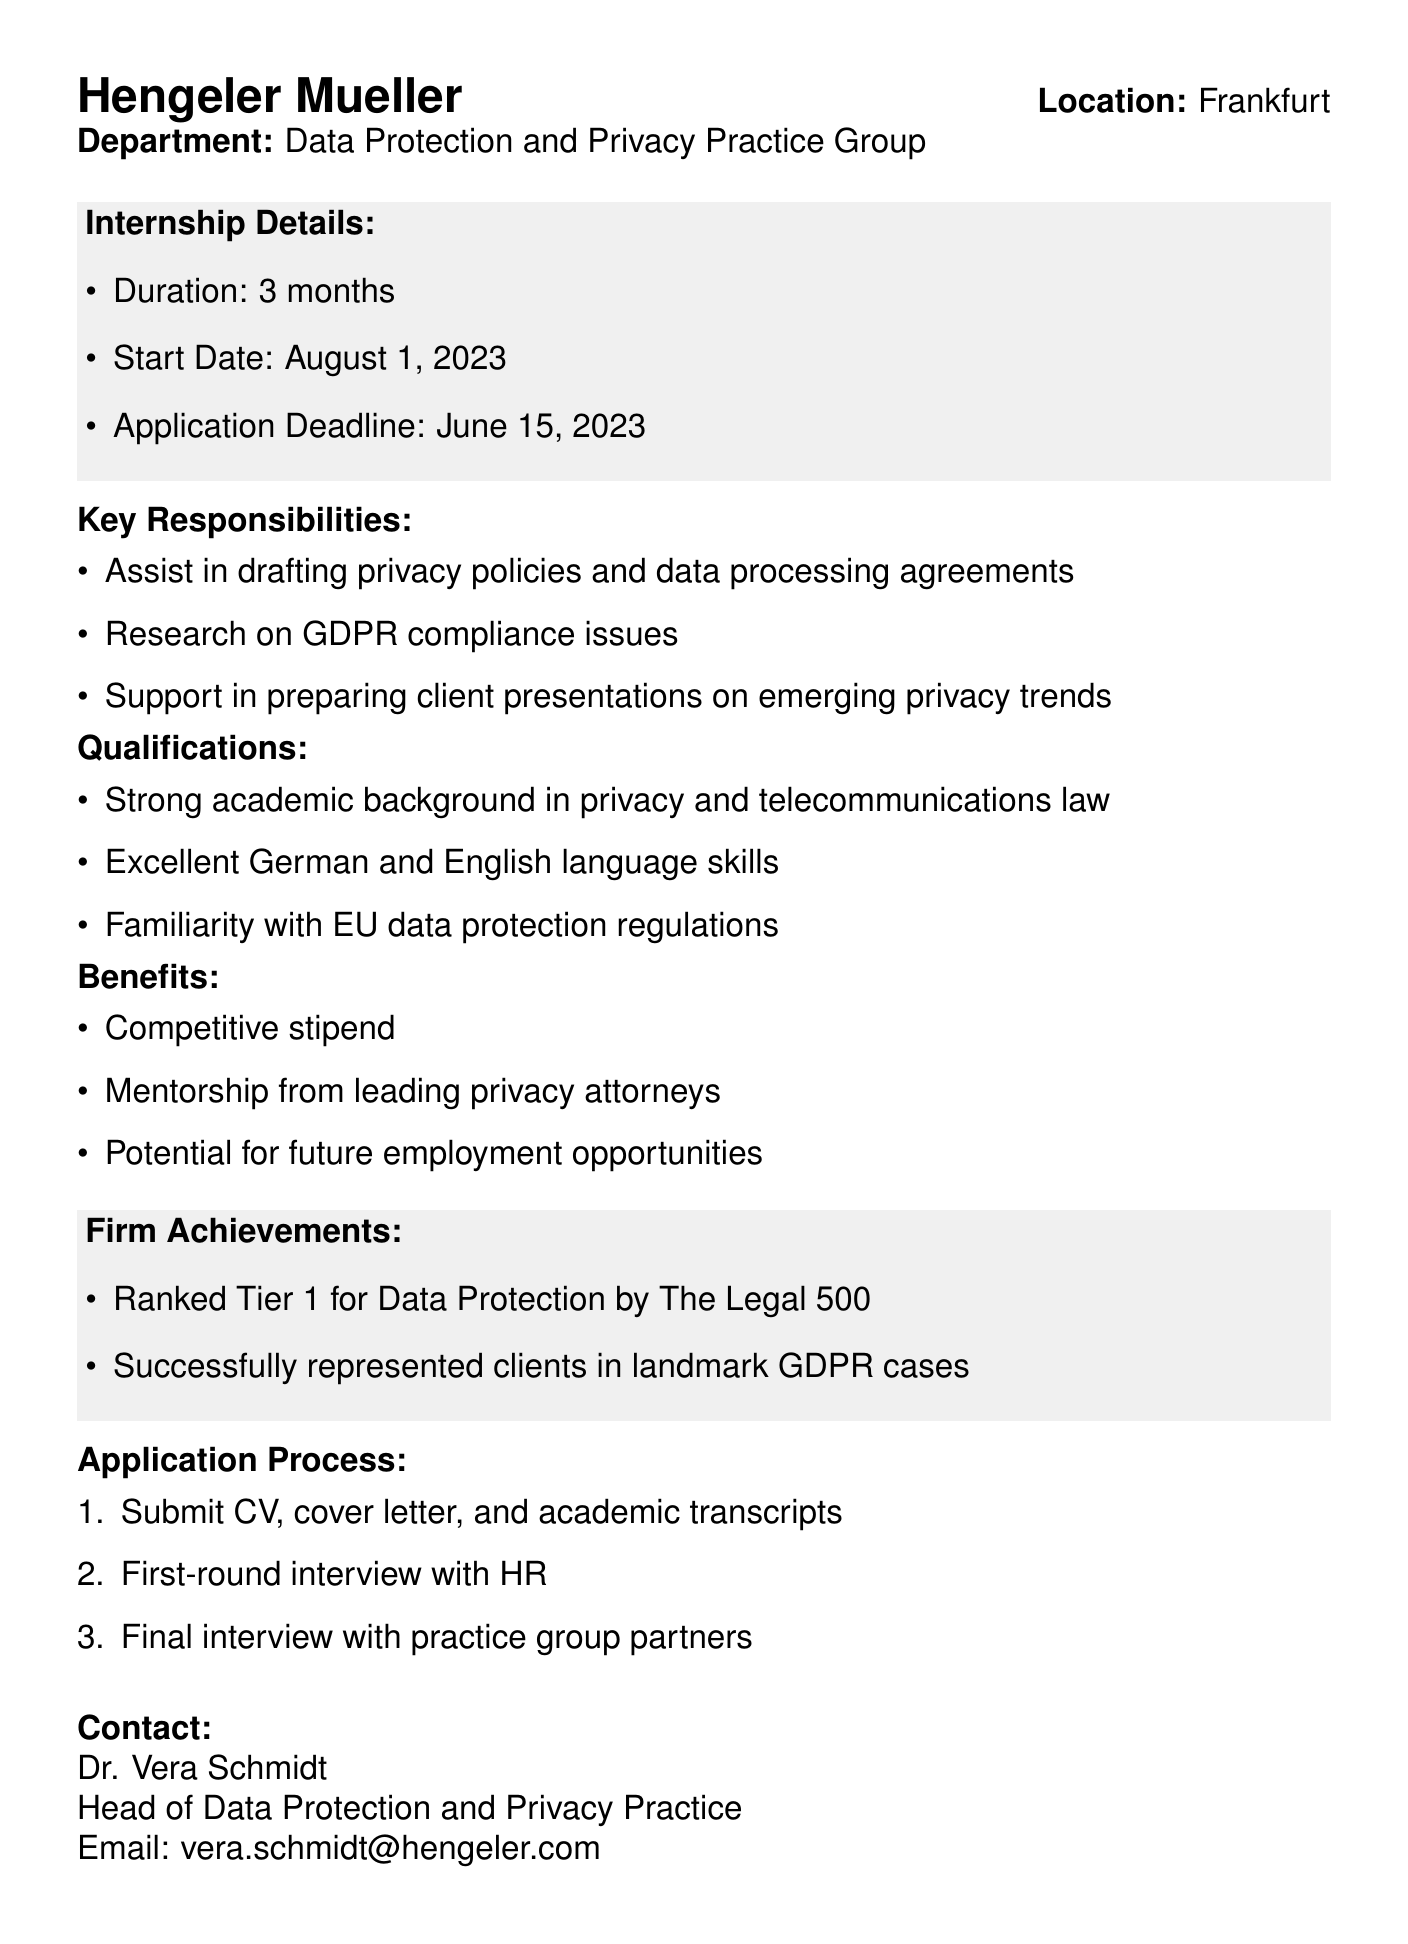What is the name of the law firm? The name of the law firm is explicitly stated at the beginning of the document.
Answer: Hengeler Mueller Where is the internship location? The location of the internship is mentioned following the law firm's name.
Answer: Frankfurt What is the duration of the internship? The document specifies the internship's duration in the intern details section.
Answer: 3 months Who is the contact person for the internship application? The contact person’s name is listed in the contact section of the document.
Answer: Dr. Vera Schmidt What are the application materials required? The document outlines the application materials needed in the application process section.
Answer: CV, cover letter, and academic transcripts What is the application deadline? The document states the application deadline clearly in the internship details section.
Answer: June 15, 2023 Which department is offering the internship? The department offering the internship is indicated shortly after the firm’s name.
Answer: Data Protection and Privacy Practice Group What benefit includes future employment opportunities? The benefits of the internship are detailed later in the document, specifically highlighting potential career advantages.
Answer: Potential for future employment opportunities What is one major achievement of the law firm? Achievements of the law firm are mentioned in their firm achievements section.
Answer: Ranked Tier 1 for Data Protection by The Legal 500 